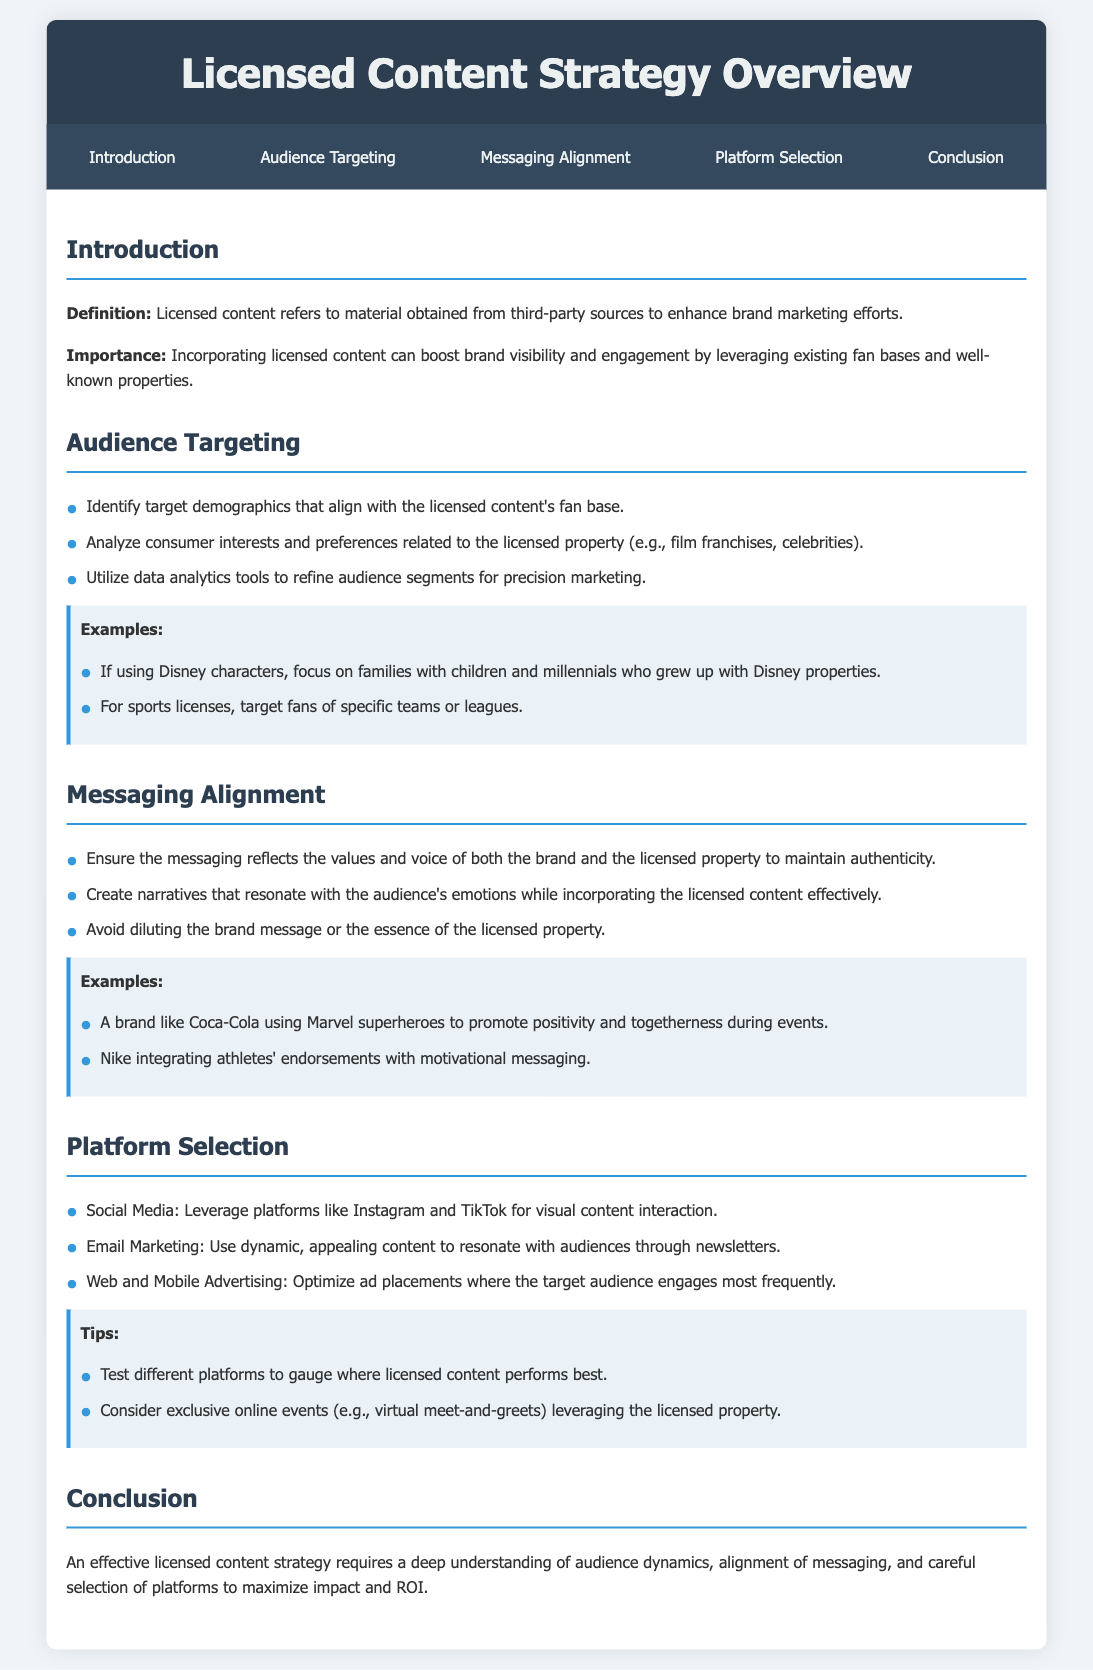what is the definition of licensed content? The definition of licensed content is provided in the introduction section, describing it as material obtained from third-party sources to enhance brand marketing efforts.
Answer: material obtained from third-party sources to enhance brand marketing efforts why is incorporating licensed content important? The importance of incorporating licensed content is mentioned in the introduction, stating it can boost brand visibility and engagement.
Answer: boost brand visibility and engagement what are the audience targeting strategies listed? The strategies for audience targeting can be found in the respective section, including identifying target demographics and analyzing consumer interests.
Answer: Identify target demographics, analyze consumer interests what should the messaging reflect according to the document? The document states that messaging should reflect the values and voice of both the brand and the licensed property.
Answer: values and voice of both the brand and the licensed property which social media platform is suggested for licensed content? The platform selection section recommends leveraging Instagram for visual content interaction.
Answer: Instagram how can email marketing be utilized in licensed content campaigns? The document indicates that email marketing can use dynamic, appealing content to resonate with audiences.
Answer: dynamic, appealing content what is an example of messaging alignment provided in the document? One example provided in the document is Coca-Cola using Marvel superheroes to promote positivity and togetherness.
Answer: Coca-Cola using Marvel superheroes what is the conclusion about an effective licensed content strategy? The conclusion emphasizes a deep understanding of audience dynamics, alignment of messaging, and careful platform selection.
Answer: understanding of audience dynamics, alignment of messaging, platform selection how many tips are given for platform selection? The tips provided in the platform selection section are two tips listed.
Answer: two tips 